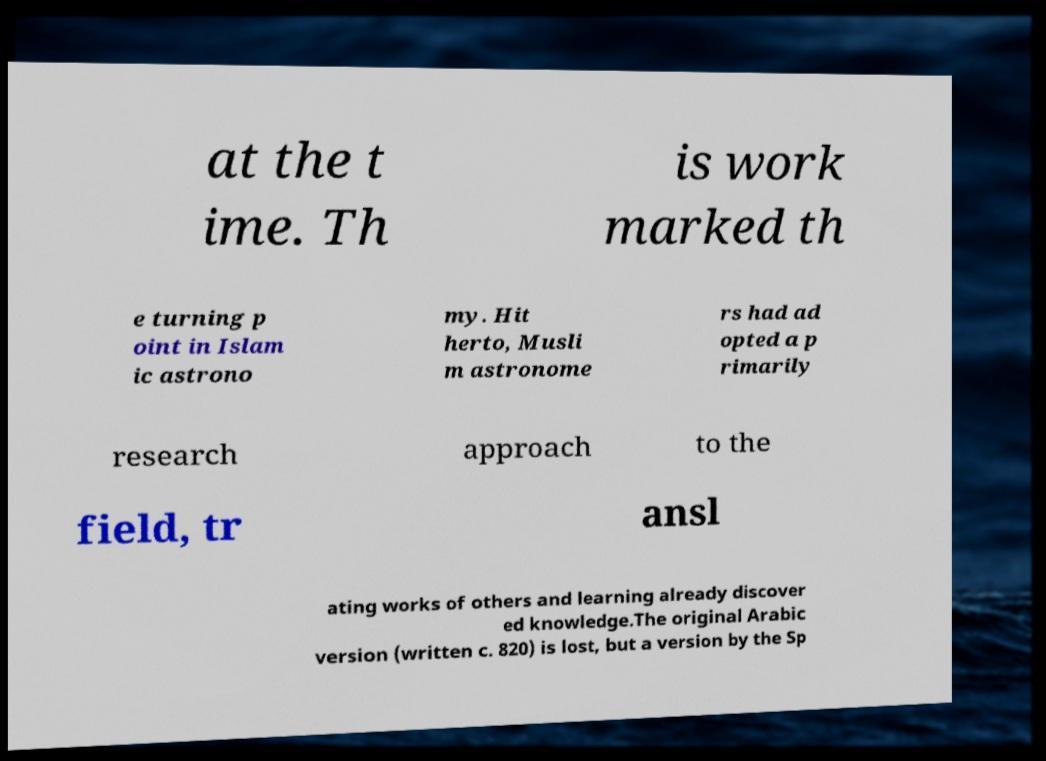Could you extract and type out the text from this image? at the t ime. Th is work marked th e turning p oint in Islam ic astrono my. Hit herto, Musli m astronome rs had ad opted a p rimarily research approach to the field, tr ansl ating works of others and learning already discover ed knowledge.The original Arabic version (written c. 820) is lost, but a version by the Sp 